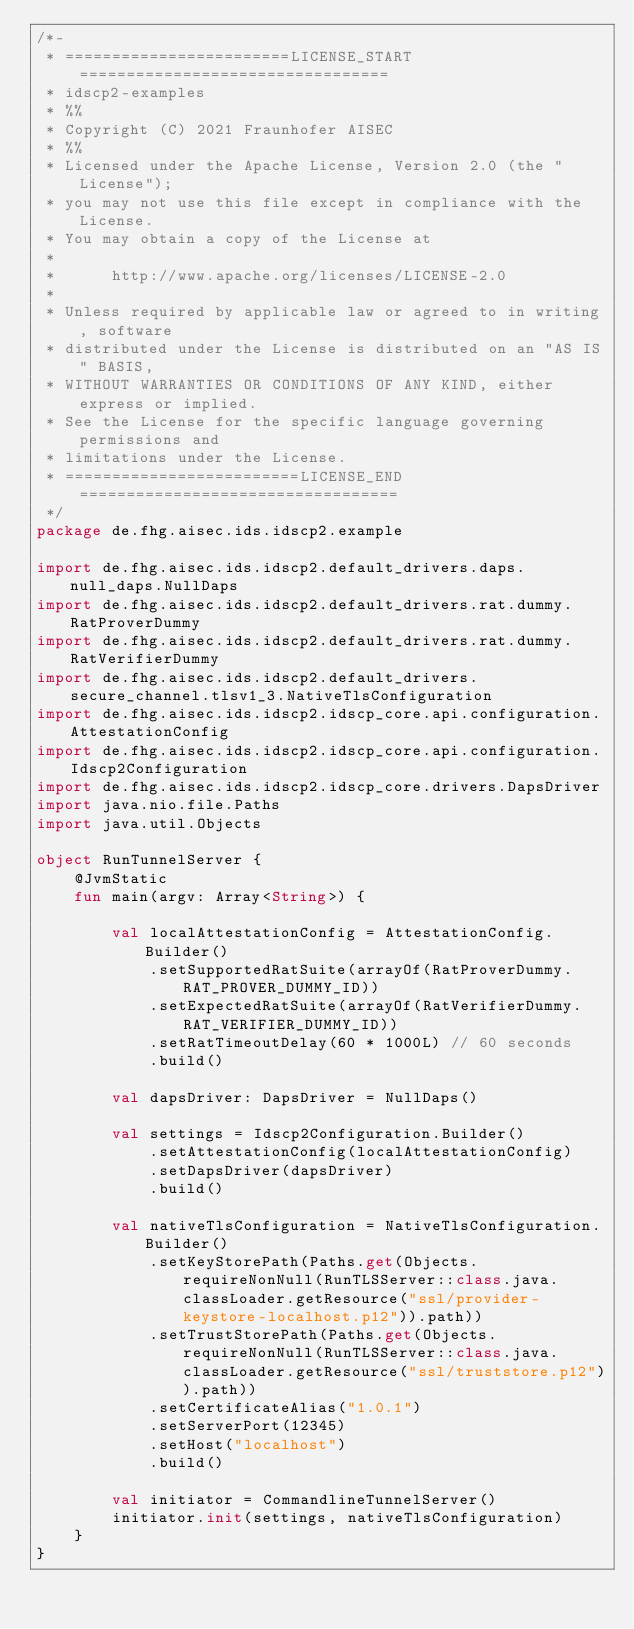<code> <loc_0><loc_0><loc_500><loc_500><_Kotlin_>/*-
 * ========================LICENSE_START=================================
 * idscp2-examples
 * %%
 * Copyright (C) 2021 Fraunhofer AISEC
 * %%
 * Licensed under the Apache License, Version 2.0 (the "License");
 * you may not use this file except in compliance with the License.
 * You may obtain a copy of the License at
 * 
 *      http://www.apache.org/licenses/LICENSE-2.0
 * 
 * Unless required by applicable law or agreed to in writing, software
 * distributed under the License is distributed on an "AS IS" BASIS,
 * WITHOUT WARRANTIES OR CONDITIONS OF ANY KIND, either express or implied.
 * See the License for the specific language governing permissions and
 * limitations under the License.
 * =========================LICENSE_END==================================
 */
package de.fhg.aisec.ids.idscp2.example

import de.fhg.aisec.ids.idscp2.default_drivers.daps.null_daps.NullDaps
import de.fhg.aisec.ids.idscp2.default_drivers.rat.dummy.RatProverDummy
import de.fhg.aisec.ids.idscp2.default_drivers.rat.dummy.RatVerifierDummy
import de.fhg.aisec.ids.idscp2.default_drivers.secure_channel.tlsv1_3.NativeTlsConfiguration
import de.fhg.aisec.ids.idscp2.idscp_core.api.configuration.AttestationConfig
import de.fhg.aisec.ids.idscp2.idscp_core.api.configuration.Idscp2Configuration
import de.fhg.aisec.ids.idscp2.idscp_core.drivers.DapsDriver
import java.nio.file.Paths
import java.util.Objects

object RunTunnelServer {
    @JvmStatic
    fun main(argv: Array<String>) {

        val localAttestationConfig = AttestationConfig.Builder()
            .setSupportedRatSuite(arrayOf(RatProverDummy.RAT_PROVER_DUMMY_ID))
            .setExpectedRatSuite(arrayOf(RatVerifierDummy.RAT_VERIFIER_DUMMY_ID))
            .setRatTimeoutDelay(60 * 1000L) // 60 seconds
            .build()

        val dapsDriver: DapsDriver = NullDaps()

        val settings = Idscp2Configuration.Builder()
            .setAttestationConfig(localAttestationConfig)
            .setDapsDriver(dapsDriver)
            .build()

        val nativeTlsConfiguration = NativeTlsConfiguration.Builder()
            .setKeyStorePath(Paths.get(Objects.requireNonNull(RunTLSServer::class.java.classLoader.getResource("ssl/provider-keystore-localhost.p12")).path))
            .setTrustStorePath(Paths.get(Objects.requireNonNull(RunTLSServer::class.java.classLoader.getResource("ssl/truststore.p12")).path))
            .setCertificateAlias("1.0.1")
            .setServerPort(12345)
            .setHost("localhost")
            .build()

        val initiator = CommandlineTunnelServer()
        initiator.init(settings, nativeTlsConfiguration)
    }
}
</code> 